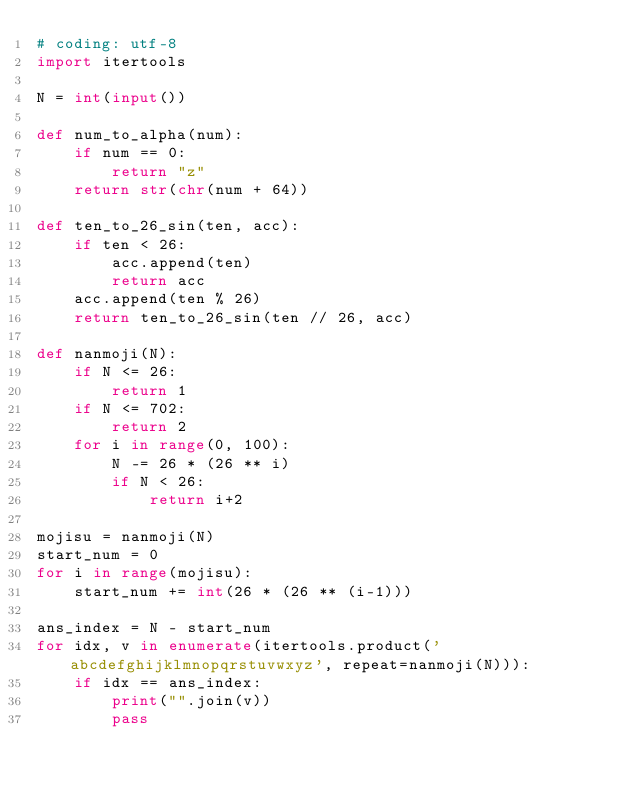<code> <loc_0><loc_0><loc_500><loc_500><_Python_># coding: utf-8
import itertools

N = int(input())

def num_to_alpha(num):
    if num == 0:
        return "z"
    return str(chr(num + 64))

def ten_to_26_sin(ten, acc):
    if ten < 26:
        acc.append(ten)
        return acc
    acc.append(ten % 26)
    return ten_to_26_sin(ten // 26, acc)

def nanmoji(N):
    if N <= 26:
        return 1
    if N <= 702:
        return 2
    for i in range(0, 100):
        N -= 26 * (26 ** i)
        if N < 26:
            return i+2

mojisu = nanmoji(N)
start_num = 0
for i in range(mojisu):
    start_num += int(26 * (26 ** (i-1)))

ans_index = N - start_num
for idx, v in enumerate(itertools.product('abcdefghijklmnopqrstuvwxyz', repeat=nanmoji(N))):
    if idx == ans_index:
        print("".join(v))
        pass
</code> 